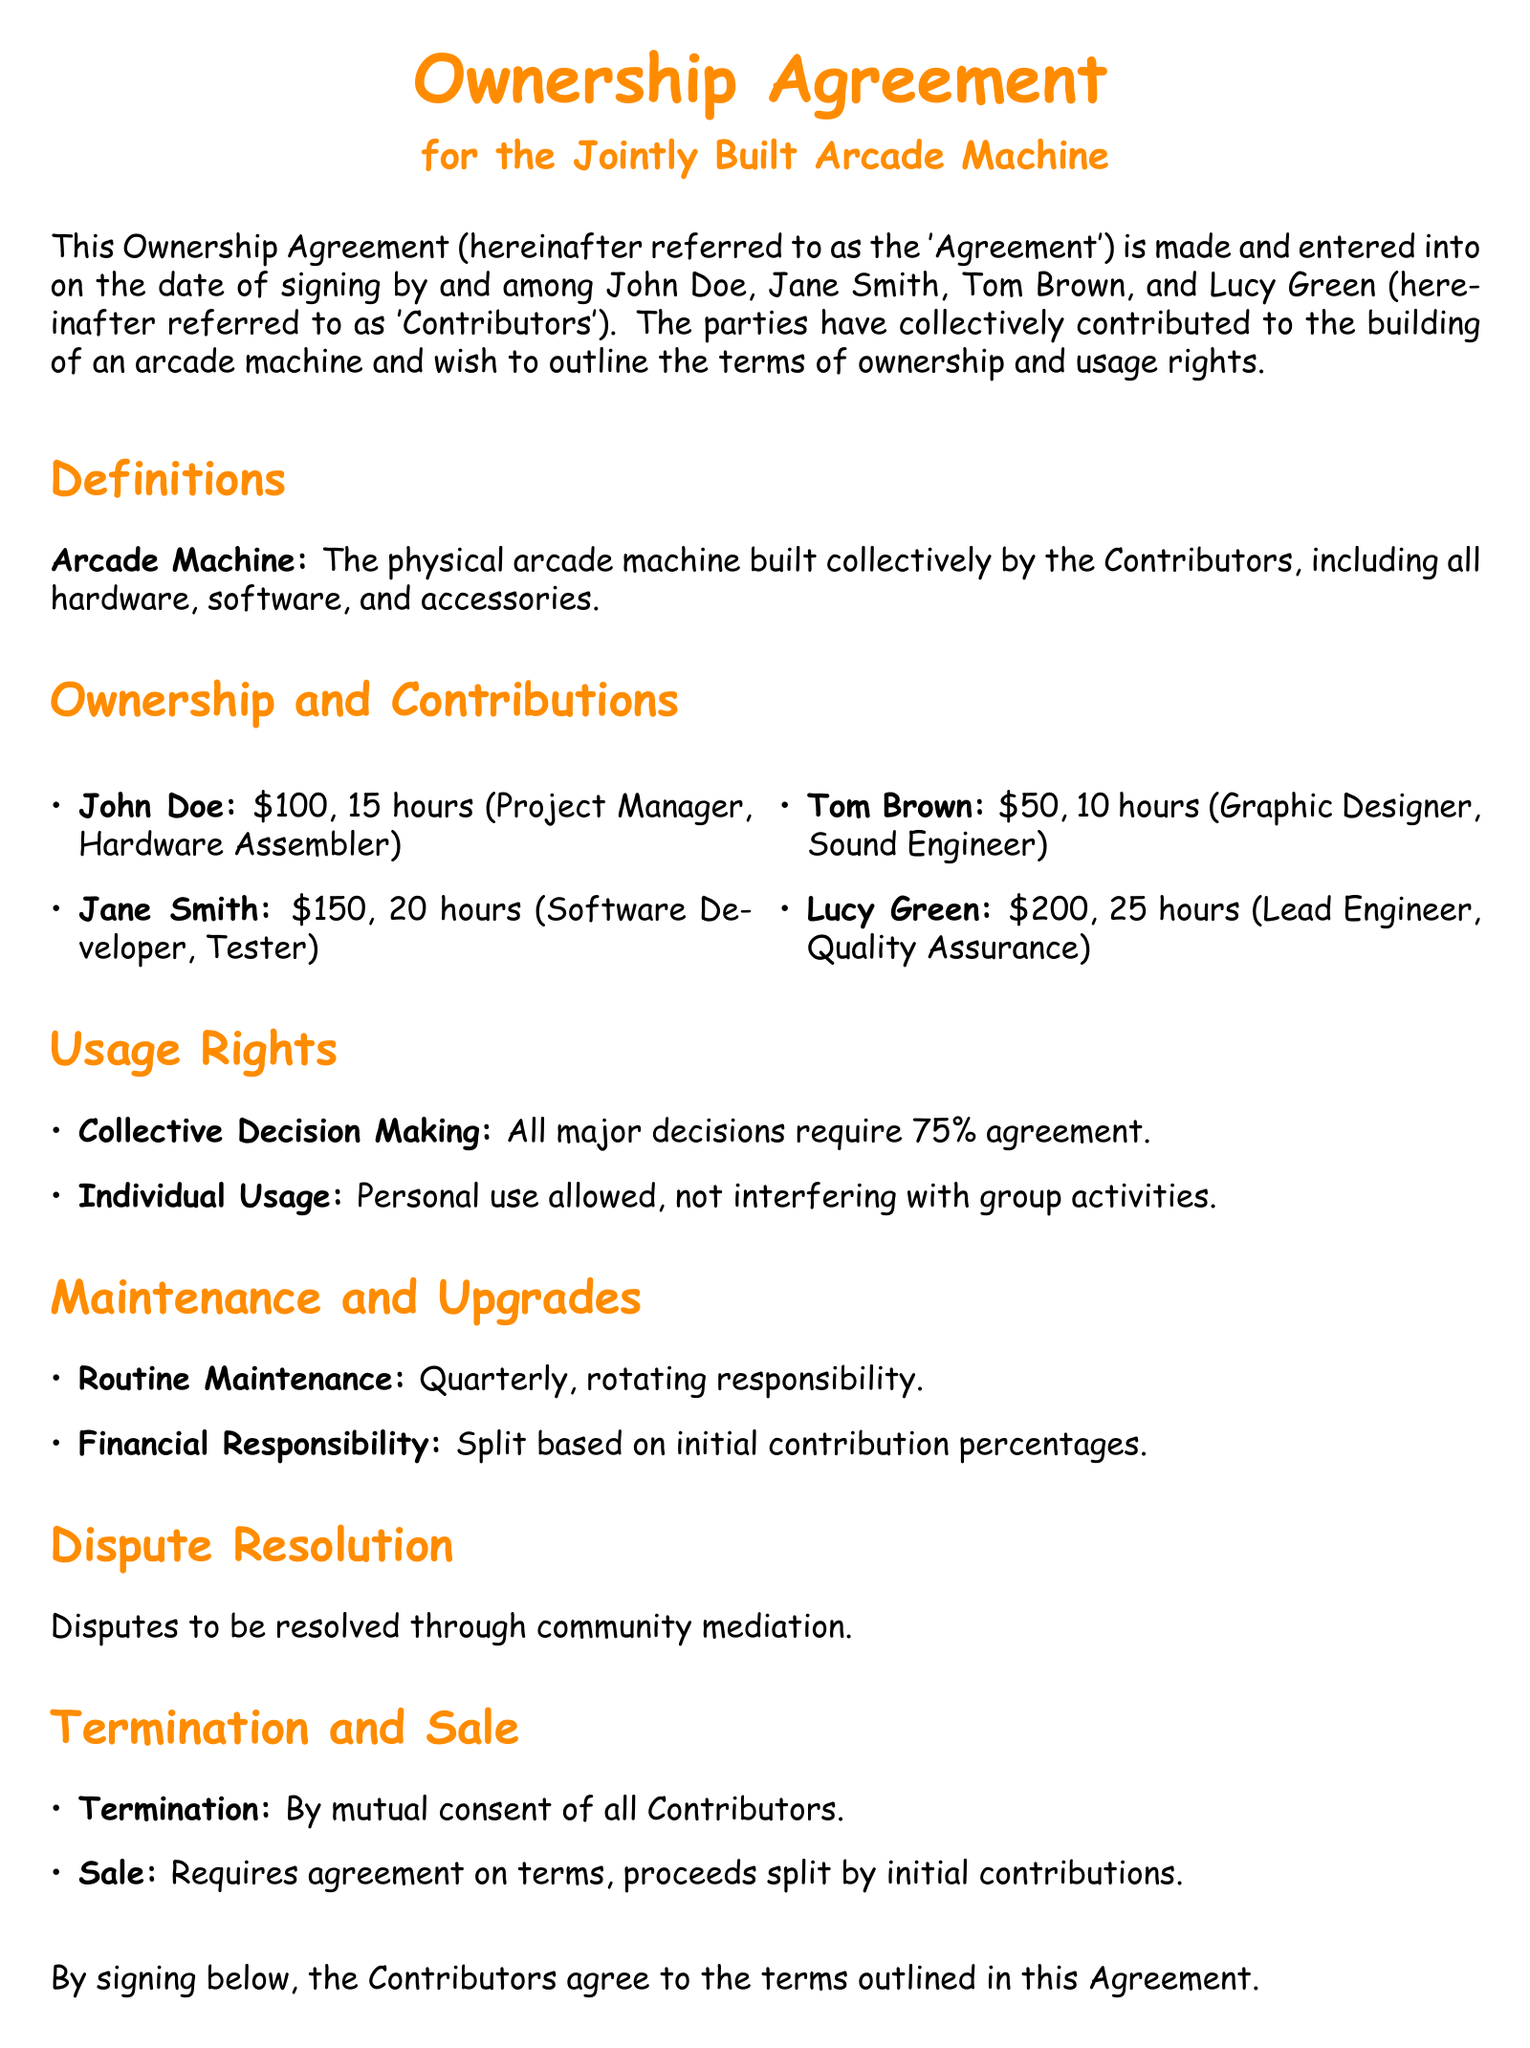What is the title of the document? The title is clearly stated at the top of the document, highlighting its purpose.
Answer: Ownership Agreement Who is the Lead Engineer among the Contributors? The Lead Engineer is mentioned along with their contributions to the project.
Answer: Lucy Green How much did Jane Smith contribute in dollars? The monetary contribution of Jane Smith is specified in the document.
Answer: $150 What is the agreed percentage required for major decisions? The percentage for decision-making is explicitly stated in the Usage Rights section.
Answer: 75% How often is routine maintenance scheduled? The maintenance frequency is mentioned under the Maintenance and Upgrades section.
Answer: Quarterly What must happen for the agreement to be terminated? The termination conditions are outlined in the relevant section of the document.
Answer: Mutual consent How should the proceeds from a sale be divided? The document specifies how sales proceeds should be allocated based on contributions.
Answer: By initial contributions What is the financial responsibility for maintenance? The financial responsibility is described in the context of contributions made by the Contributors.
Answer: Split based on initial contribution percentages 